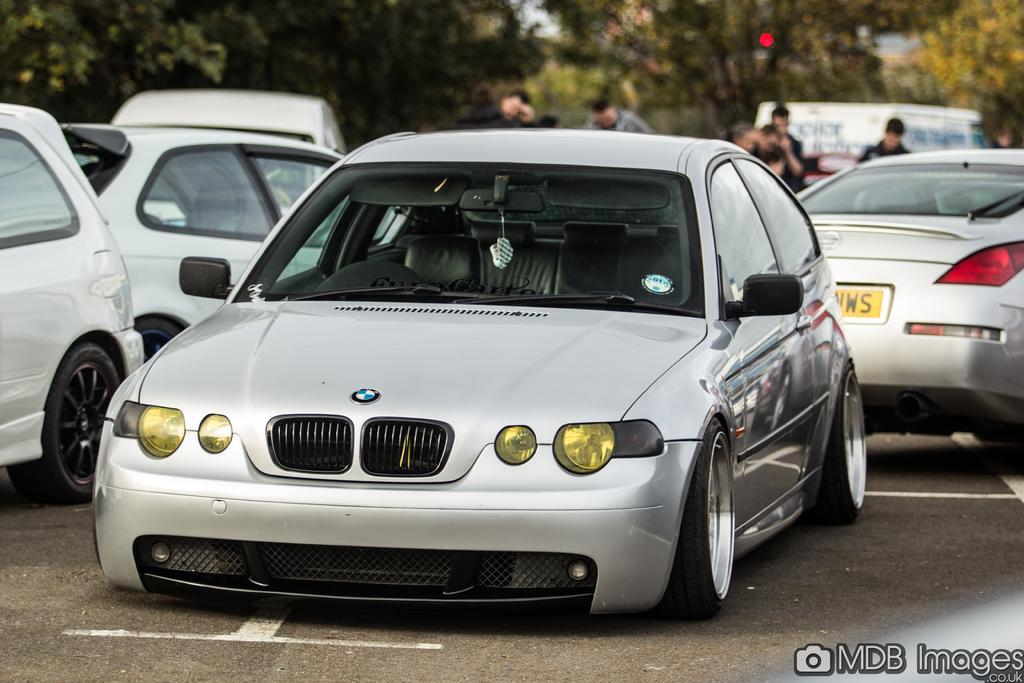Describe this image in one or two sentences. In this picture we can see cars and some persons on the road and in the background we can see trees. 